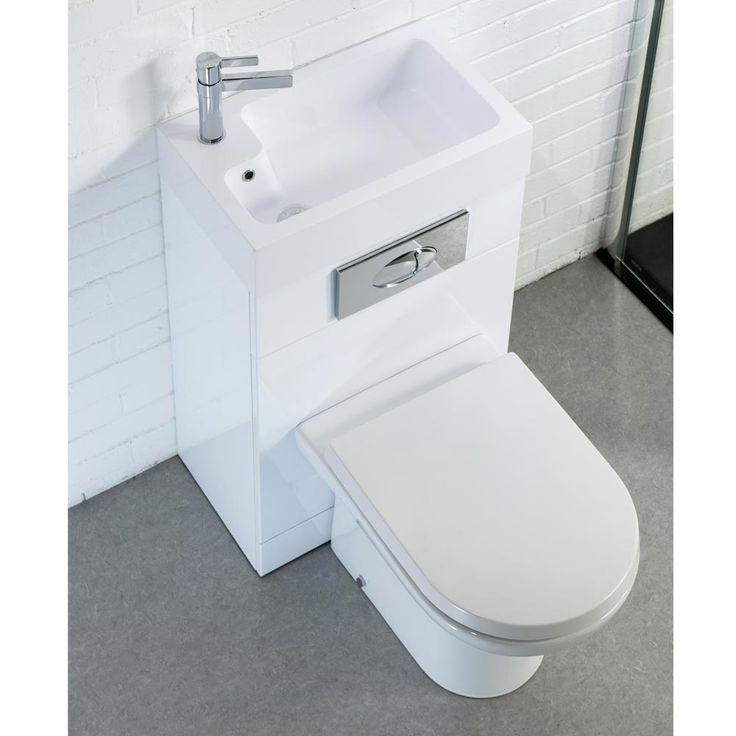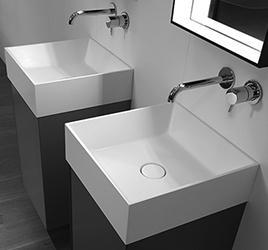The first image is the image on the left, the second image is the image on the right. For the images displayed, is the sentence "There are at least two rectangular basins." factually correct? Answer yes or no. Yes. The first image is the image on the left, the second image is the image on the right. Analyze the images presented: Is the assertion "An image shows at least one square white sink atop a black base and under a spout mounted to the wall." valid? Answer yes or no. Yes. 